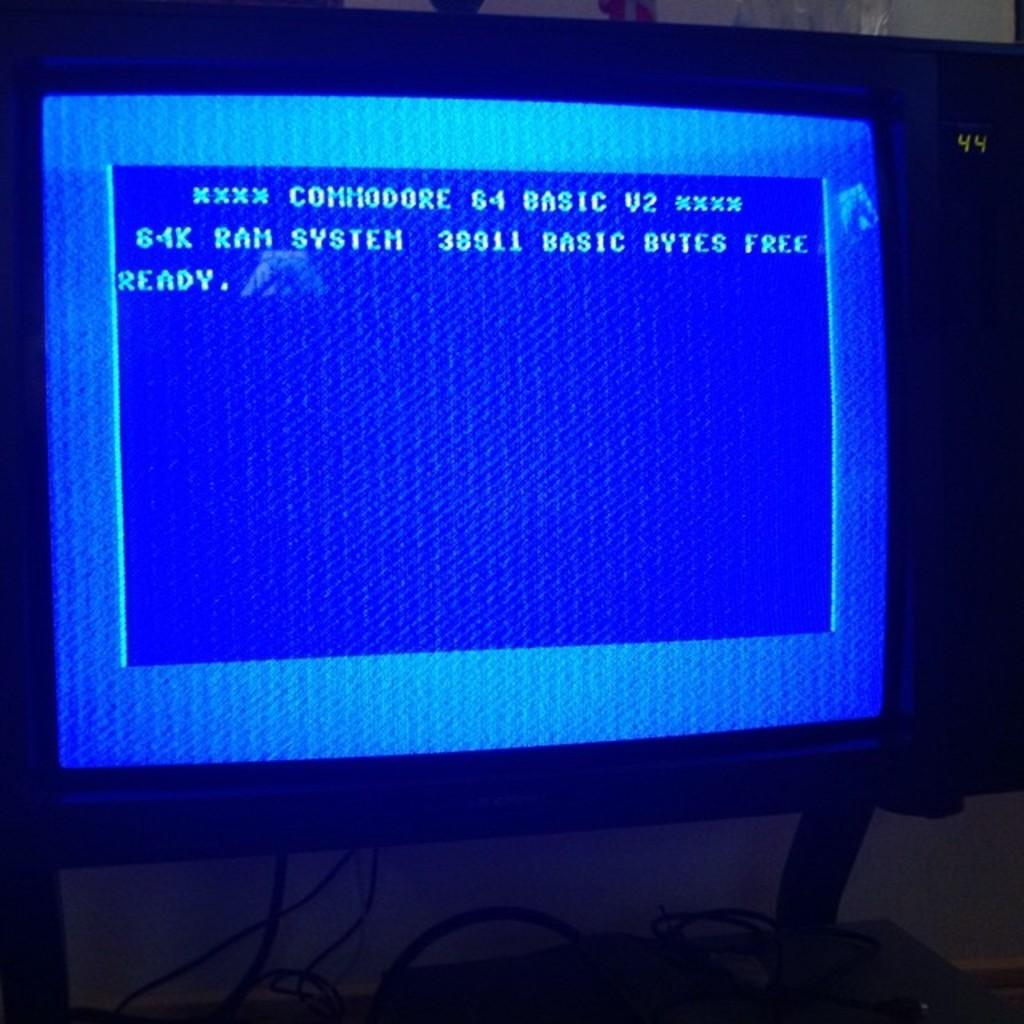<image>
Offer a succinct explanation of the picture presented. A blue computer screen with Commodore 64 written on it 